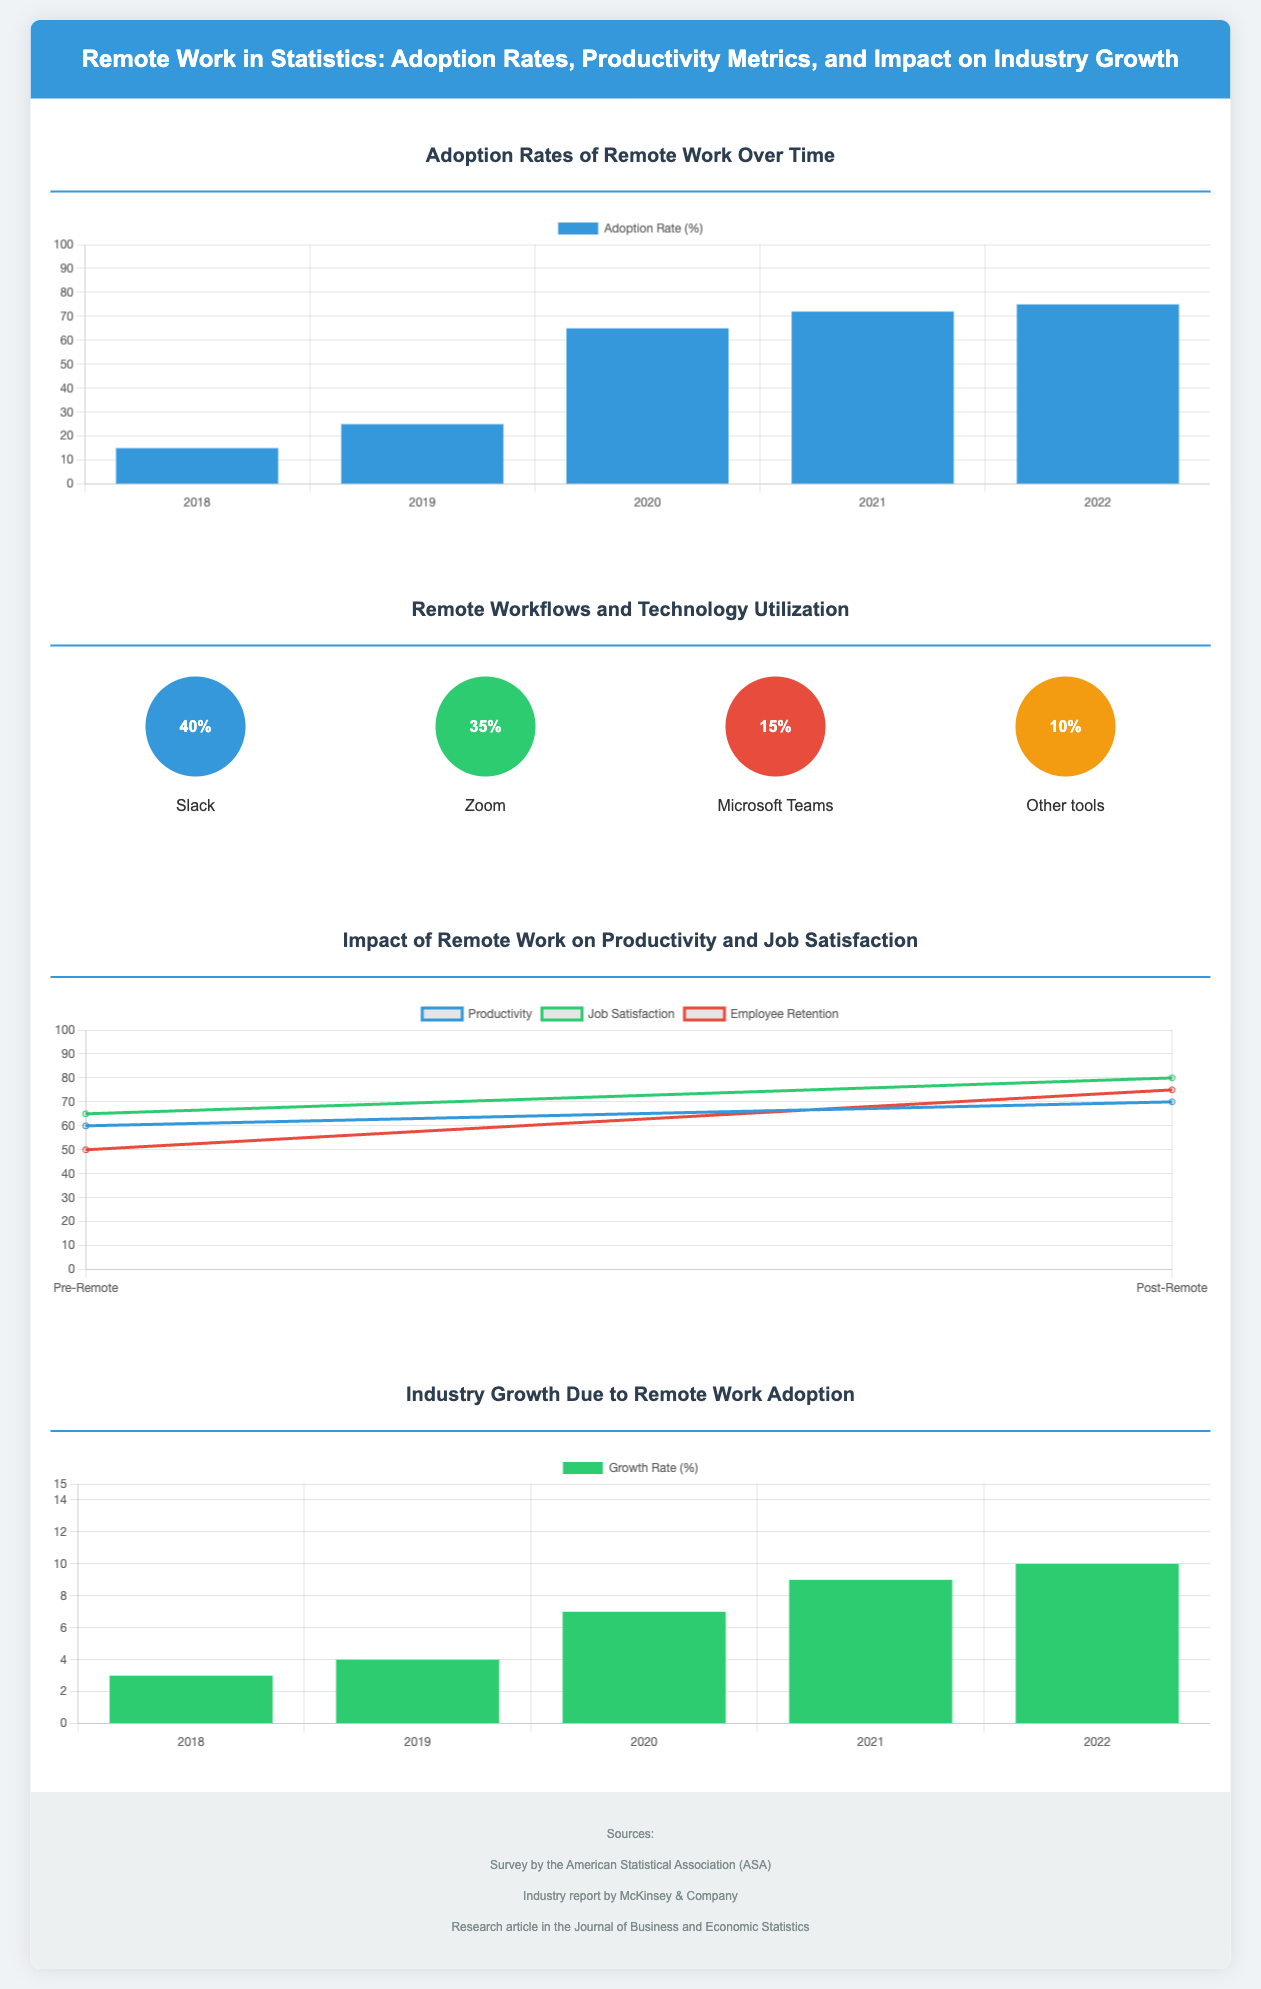What was the adoption rate of remote work in 2020? The adoption rate for remote work in 2020 is shown in the bar chart as 65%.
Answer: 65% What is the percentage utilization of Slack in remote workflows? The infographic indicates that Slack has a utilization rate of 40% in remote workflows.
Answer: 40% Which technology has the lowest utilization in remote workflows? The infographic shows that "Other tools" have the lowest utilization at 10%.
Answer: 10% What was the job satisfaction percentage after remote work adoption? The line chart indicates that job satisfaction increased to 80% post-remote work.
Answer: 80% Which year showed the highest growth rate? The growth chart shows that the highest growth rate was in 2022 at 10%.
Answer: 10% What percentage increase in productivity was observed post-remote work? The productivity increased from 60% to 70%, which is an increase of 10%.
Answer: 10% How much did employee retention improve after remote work? The employee retention rate improved from 50% pre-remote to 75% post-remote work, an increase of 25%.
Answer: 25% Which survey source is cited in the infographic? The sources mentioned include the "Survey by the American Statistical Association (ASA)."
Answer: ASA What type of chart represents the adoption rates? The adoption rates are represented using a bar chart.
Answer: Bar Chart 